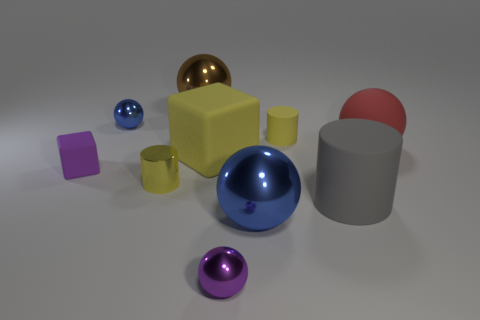What number of other objects are the same material as the big cylinder?
Offer a terse response. 4. Are there more blue spheres to the left of the purple shiny object than big cubes that are behind the red ball?
Provide a short and direct response. Yes. There is a purple object behind the small yellow metal cylinder; what is it made of?
Provide a succinct answer. Rubber. Do the small yellow matte thing and the gray thing have the same shape?
Your answer should be very brief. Yes. Is there anything else of the same color as the metal cylinder?
Give a very brief answer. Yes. There is a big matte object that is the same shape as the tiny blue thing; what is its color?
Offer a terse response. Red. Are there more tiny matte objects in front of the red object than big gray rubber blocks?
Provide a short and direct response. Yes. There is a sphere that is on the left side of the brown metallic sphere; what color is it?
Provide a short and direct response. Blue. Is the rubber sphere the same size as the gray matte thing?
Ensure brevity in your answer.  Yes. The red sphere is what size?
Give a very brief answer. Large. 